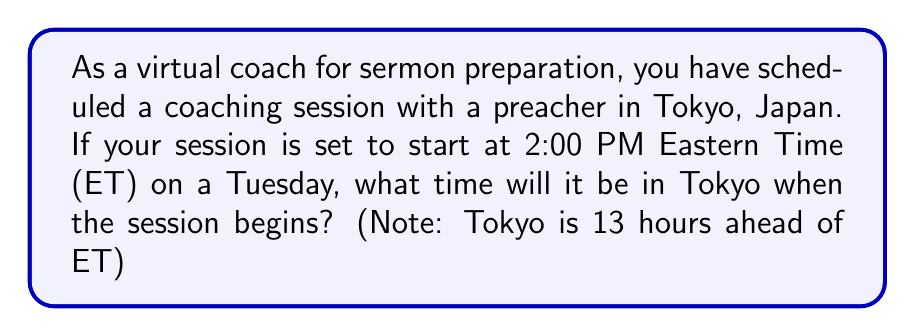Solve this math problem. Let's approach this step-by-step:

1) First, we need to understand the time difference:
   Tokyo is 13 hours ahead of Eastern Time (ET)

2) We're given that the session starts at 2:00 PM ET on Tuesday

3) To find the time in Tokyo, we add 13 hours to 2:00 PM:
   $2:00 \text{ PM} + 13 \text{ hours} = 3:00 \text{ AM}$ (of the next day)

4) Since we're adding 13 hours, we're crossing midnight, which means we're moving to the next day

5) Therefore, when it's 2:00 PM Tuesday in ET, it will be 3:00 AM Wednesday in Tokyo

This calculation can be represented mathematically as:

$$\text{Tokyo Time} = (\text{ET} + 13) \mod 24$$

Where $\mod 24$ ensures we stay within a 24-hour cycle.
Answer: 3:00 AM Wednesday 